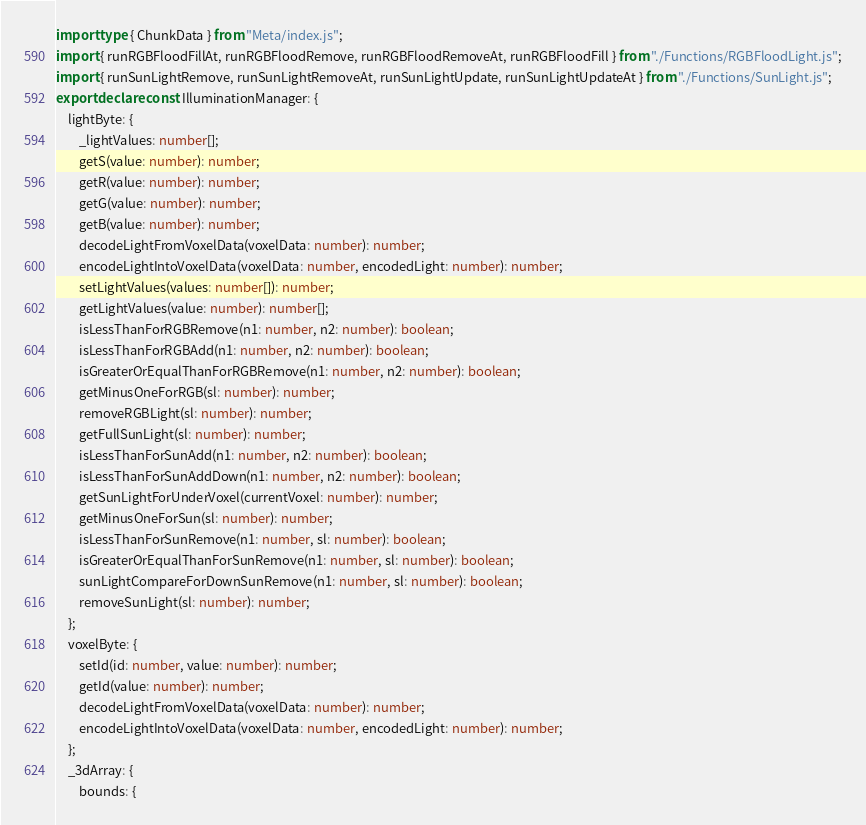<code> <loc_0><loc_0><loc_500><loc_500><_TypeScript_>import type { ChunkData } from "Meta/index.js";
import { runRGBFloodFillAt, runRGBFloodRemove, runRGBFloodRemoveAt, runRGBFloodFill } from "./Functions/RGBFloodLight.js";
import { runSunLightRemove, runSunLightRemoveAt, runSunLightUpdate, runSunLightUpdateAt } from "./Functions/SunLight.js";
export declare const IlluminationManager: {
    lightByte: {
        _lightValues: number[];
        getS(value: number): number;
        getR(value: number): number;
        getG(value: number): number;
        getB(value: number): number;
        decodeLightFromVoxelData(voxelData: number): number;
        encodeLightIntoVoxelData(voxelData: number, encodedLight: number): number;
        setLightValues(values: number[]): number;
        getLightValues(value: number): number[];
        isLessThanForRGBRemove(n1: number, n2: number): boolean;
        isLessThanForRGBAdd(n1: number, n2: number): boolean;
        isGreaterOrEqualThanForRGBRemove(n1: number, n2: number): boolean;
        getMinusOneForRGB(sl: number): number;
        removeRGBLight(sl: number): number;
        getFullSunLight(sl: number): number;
        isLessThanForSunAdd(n1: number, n2: number): boolean;
        isLessThanForSunAddDown(n1: number, n2: number): boolean;
        getSunLightForUnderVoxel(currentVoxel: number): number;
        getMinusOneForSun(sl: number): number;
        isLessThanForSunRemove(n1: number, sl: number): boolean;
        isGreaterOrEqualThanForSunRemove(n1: number, sl: number): boolean;
        sunLightCompareForDownSunRemove(n1: number, sl: number): boolean;
        removeSunLight(sl: number): number;
    };
    voxelByte: {
        setId(id: number, value: number): number;
        getId(value: number): number;
        decodeLightFromVoxelData(voxelData: number): number;
        encodeLightIntoVoxelData(voxelData: number, encodedLight: number): number;
    };
    _3dArray: {
        bounds: {</code> 